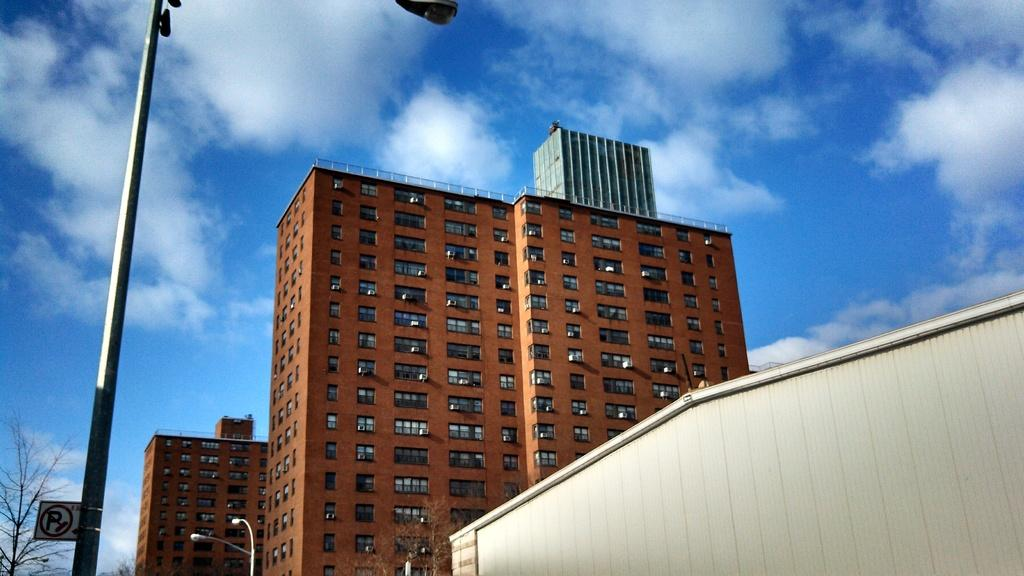What type of structures can be seen in the image? There are buildings in the image. What feature of the buildings is visible? There are windows visible in the image. What type of street furniture is present in the image? There are light poles in the image. What type of vegetation can be seen in the image? Dry trees are present in the image. What part of the natural environment is visible in the image? The sky is visible in the image. What type of signage is present in the image? There is a sign board attached to a pole in the image. What type of belief is being expressed by the band in the image? There is no band present in the image, so it is not possible to determine what belief they might be expressing. 